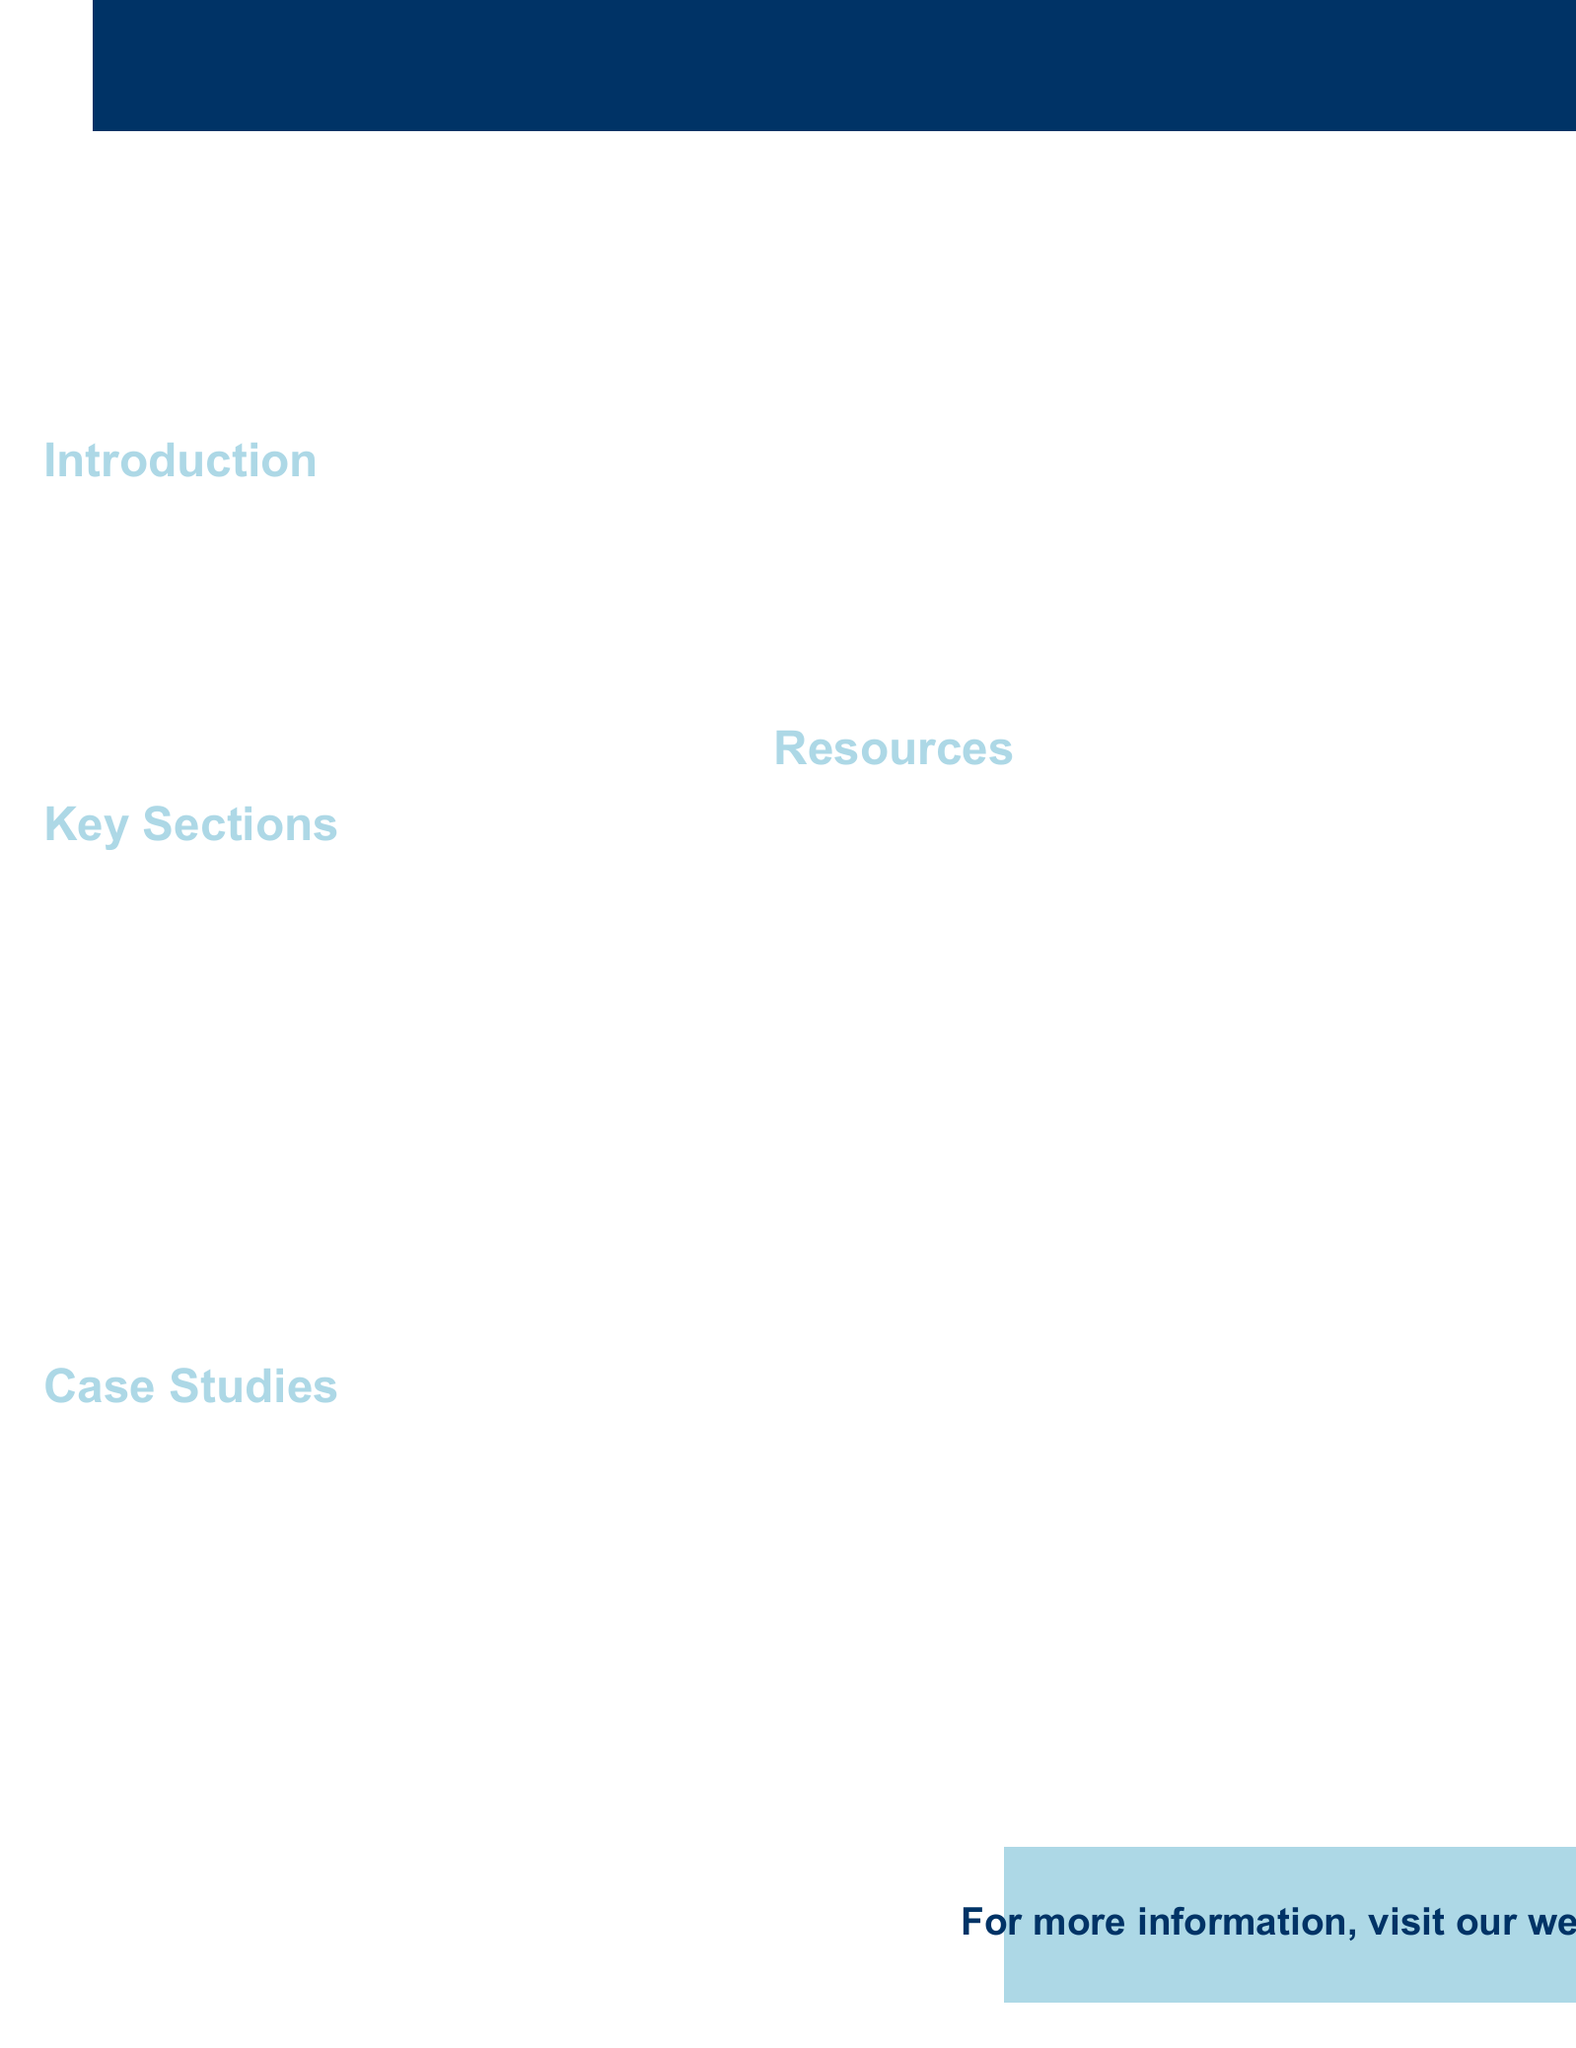What is the title of the brochure? The title is prominently displayed at the top of the document, which serves as the main heading.
Answer: Mastering Ethnographic Fieldwork: A Comprehensive Guide for Graduate Students Who is the researcher of the case study focusing on gender and robotics in Japan? The case studies list the researchers along with their respective focuses, showcasing their work.
Answer: Dr. Jennifer Robertson What is one of the key methods used in rural fieldwork in the Peruvian Amazon? The case study on rural fieldwork details the methods employed for research in a specific cultural setting.
Answer: Extended stays in Ávila village Which organization is listed as a professional association? A section of the brochure outlines various professional associations related to anthropology.
Answer: American Anthropological Association What type of data analysis technique involves identifying patterns? The section on data analysis includes different methods used in processing collected data.
Answer: Thematic analysis What is a suggested online course platform for qualitative research methods? The resources section mentions various platforms offering relevant courses for graduate students.
Answer: Coursera What is one cultural consideration for building rapport mentioned in the document? The guide provides insights on engaging respectfully with cultures when conducting fieldwork.
Answer: Navigating local customs What is one coping strategy mentioned for culture shock? The challenges section addresses potential difficulties faced during fieldwork, along with solutions.
Answer: Coping strategies and support networks 